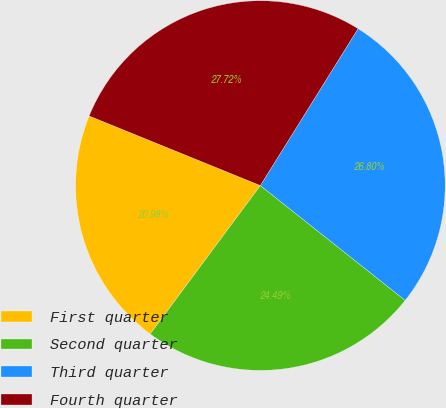<chart> <loc_0><loc_0><loc_500><loc_500><pie_chart><fcel>First quarter<fcel>Second quarter<fcel>Third quarter<fcel>Fourth quarter<nl><fcel>20.98%<fcel>24.49%<fcel>26.8%<fcel>27.72%<nl></chart> 